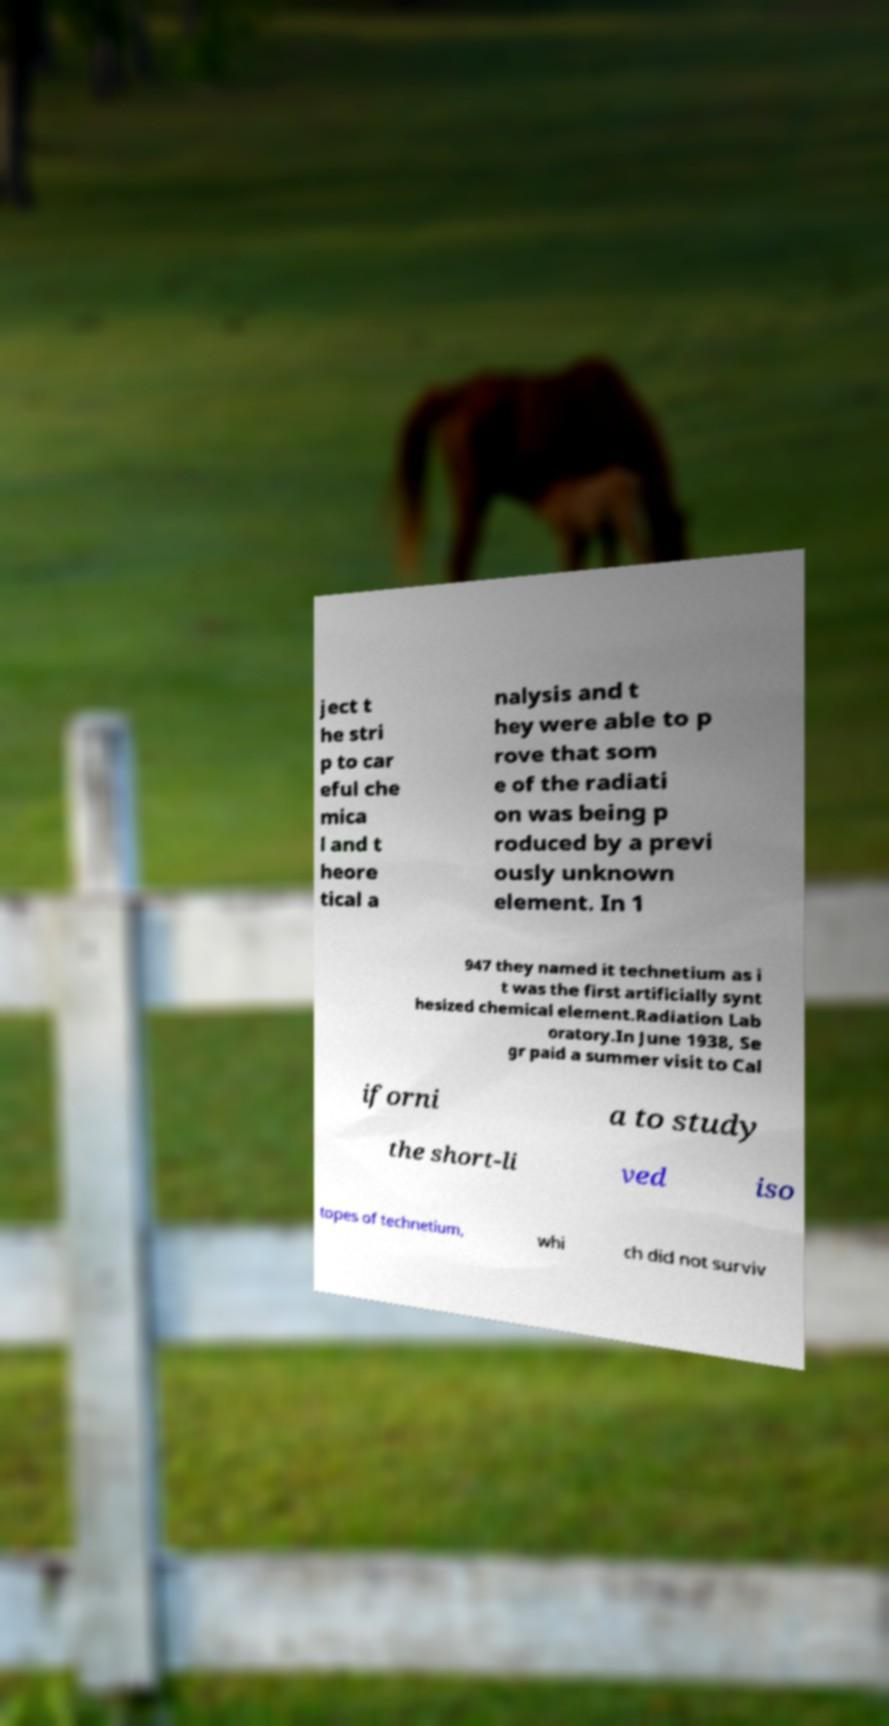Can you read and provide the text displayed in the image?This photo seems to have some interesting text. Can you extract and type it out for me? ject t he stri p to car eful che mica l and t heore tical a nalysis and t hey were able to p rove that som e of the radiati on was being p roduced by a previ ously unknown element. In 1 947 they named it technetium as i t was the first artificially synt hesized chemical element.Radiation Lab oratory.In June 1938, Se gr paid a summer visit to Cal iforni a to study the short-li ved iso topes of technetium, whi ch did not surviv 